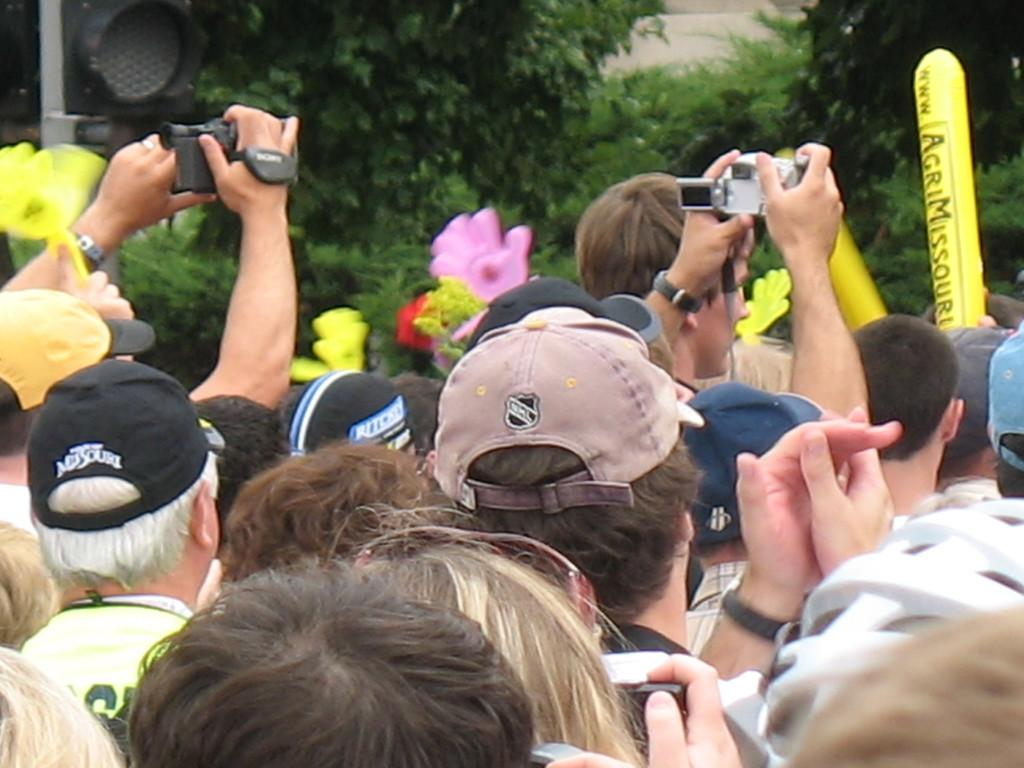How many people are in the image? There is a group of persons in the image. What are the persons in the image doing? The persons are standing and holding a camera in their hands. What can be seen in the background of the image? There is a traffic signal and trees in the image. What type of fruit is being held by the son in the image? There is no son or fruit present in the image. What kind of pain is the person in the image experiencing? There is no indication of pain or discomfort in the image. 